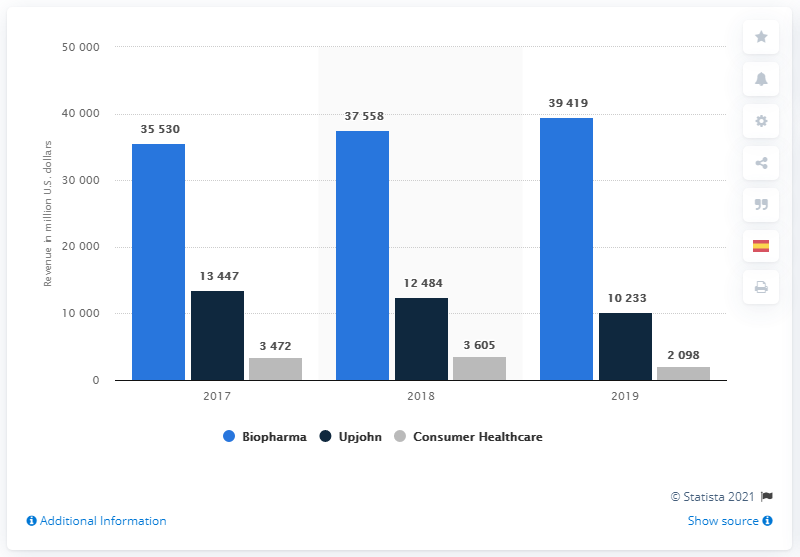Highlight a few significant elements in this photo. In 2019, Pfizer's Consumer Healthcare business merged with GlaxoSmithKline (GSK) in the biopharmaceutical segment. Pfizer's Biopharma segment generated a revenue of 39,419 in 2019. 